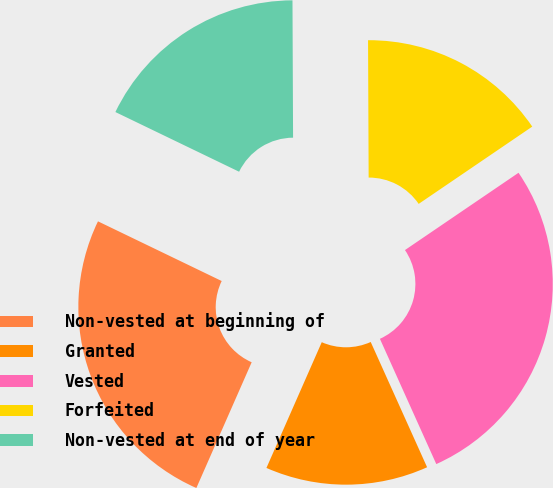<chart> <loc_0><loc_0><loc_500><loc_500><pie_chart><fcel>Non-vested at beginning of<fcel>Granted<fcel>Vested<fcel>Forfeited<fcel>Non-vested at end of year<nl><fcel>25.56%<fcel>13.33%<fcel>27.78%<fcel>15.56%<fcel>17.78%<nl></chart> 